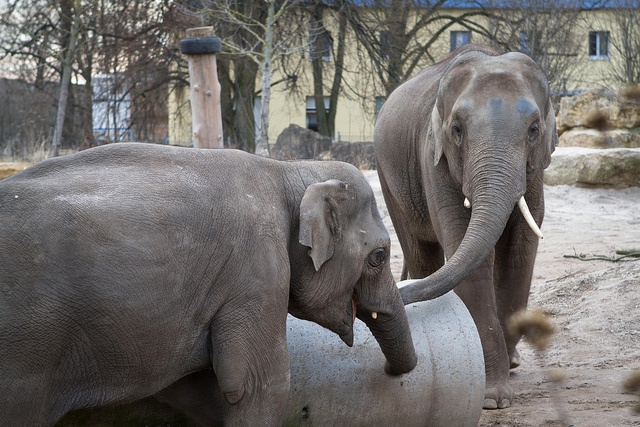Describe the objects in this image and their specific colors. I can see elephant in lightgray, gray, black, and darkgray tones and elephant in lightgray, gray, darkgray, and black tones in this image. 